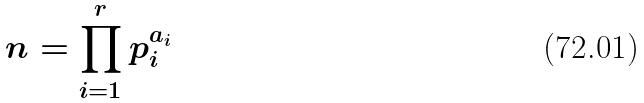<formula> <loc_0><loc_0><loc_500><loc_500>n = \prod _ { i = 1 } ^ { r } p _ { i } ^ { a _ { i } }</formula> 